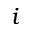<formula> <loc_0><loc_0><loc_500><loc_500>i</formula> 